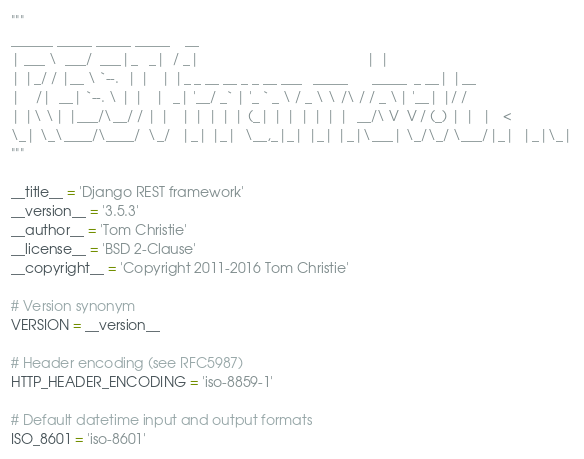Convert code to text. <code><loc_0><loc_0><loc_500><loc_500><_Python_>"""
______ _____ _____ _____    __
| ___ \  ___/  ___|_   _|  / _|                                           | |
| |_/ / |__ \ `--.  | |   | |_ _ __ __ _ _ __ ___   _____      _____  _ __| |__
|    /|  __| `--. \ | |   |  _| '__/ _` | '_ ` _ \ / _ \ \ /\ / / _ \| '__| |/ /
| |\ \| |___/\__/ / | |   | | | | | (_| | | | | | |  __/\ V  V / (_) | |  |   <
\_| \_\____/\____/  \_/   |_| |_|  \__,_|_| |_| |_|\___| \_/\_/ \___/|_|  |_|\_|
"""

__title__ = 'Django REST framework'
__version__ = '3.5.3'
__author__ = 'Tom Christie'
__license__ = 'BSD 2-Clause'
__copyright__ = 'Copyright 2011-2016 Tom Christie'

# Version synonym
VERSION = __version__

# Header encoding (see RFC5987)
HTTP_HEADER_ENCODING = 'iso-8859-1'

# Default datetime input and output formats
ISO_8601 = 'iso-8601'
</code> 